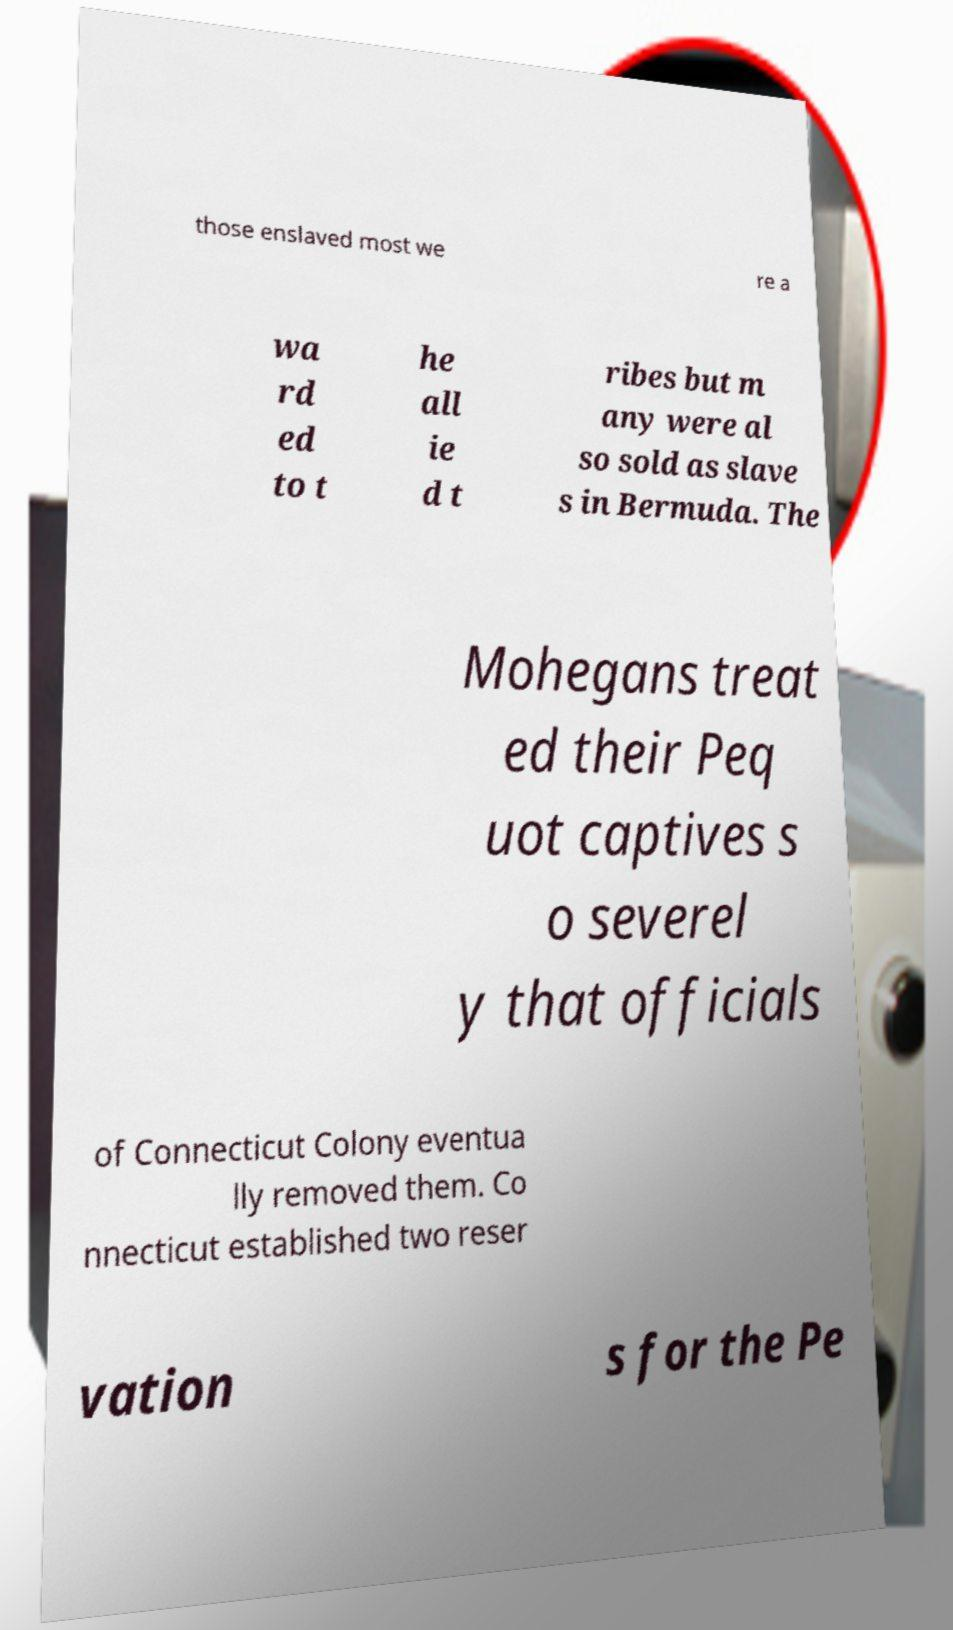I need the written content from this picture converted into text. Can you do that? those enslaved most we re a wa rd ed to t he all ie d t ribes but m any were al so sold as slave s in Bermuda. The Mohegans treat ed their Peq uot captives s o severel y that officials of Connecticut Colony eventua lly removed them. Co nnecticut established two reser vation s for the Pe 